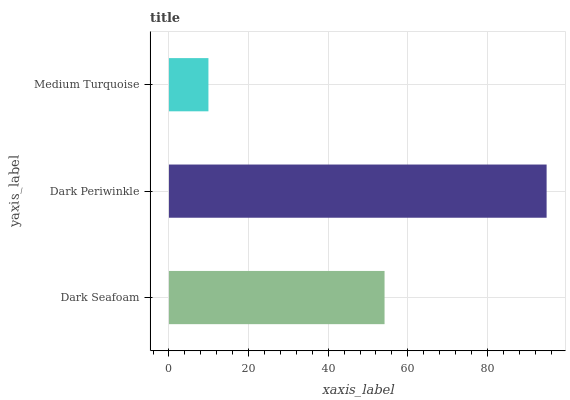Is Medium Turquoise the minimum?
Answer yes or no. Yes. Is Dark Periwinkle the maximum?
Answer yes or no. Yes. Is Dark Periwinkle the minimum?
Answer yes or no. No. Is Medium Turquoise the maximum?
Answer yes or no. No. Is Dark Periwinkle greater than Medium Turquoise?
Answer yes or no. Yes. Is Medium Turquoise less than Dark Periwinkle?
Answer yes or no. Yes. Is Medium Turquoise greater than Dark Periwinkle?
Answer yes or no. No. Is Dark Periwinkle less than Medium Turquoise?
Answer yes or no. No. Is Dark Seafoam the high median?
Answer yes or no. Yes. Is Dark Seafoam the low median?
Answer yes or no. Yes. Is Dark Periwinkle the high median?
Answer yes or no. No. Is Medium Turquoise the low median?
Answer yes or no. No. 